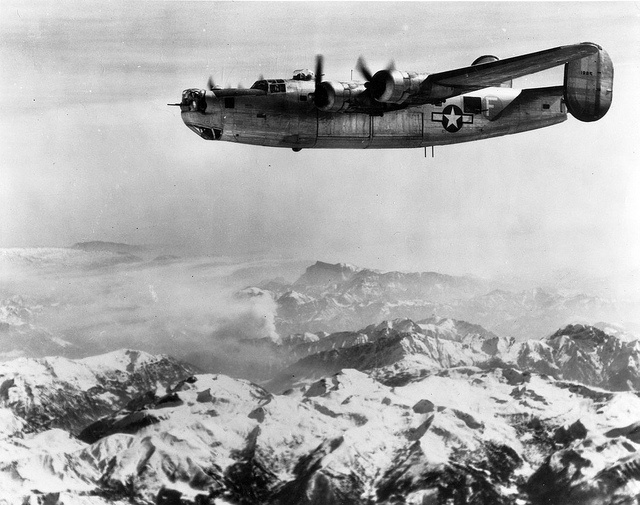Describe the objects in this image and their specific colors. I can see a airplane in white, black, gray, lightgray, and darkgray tones in this image. 